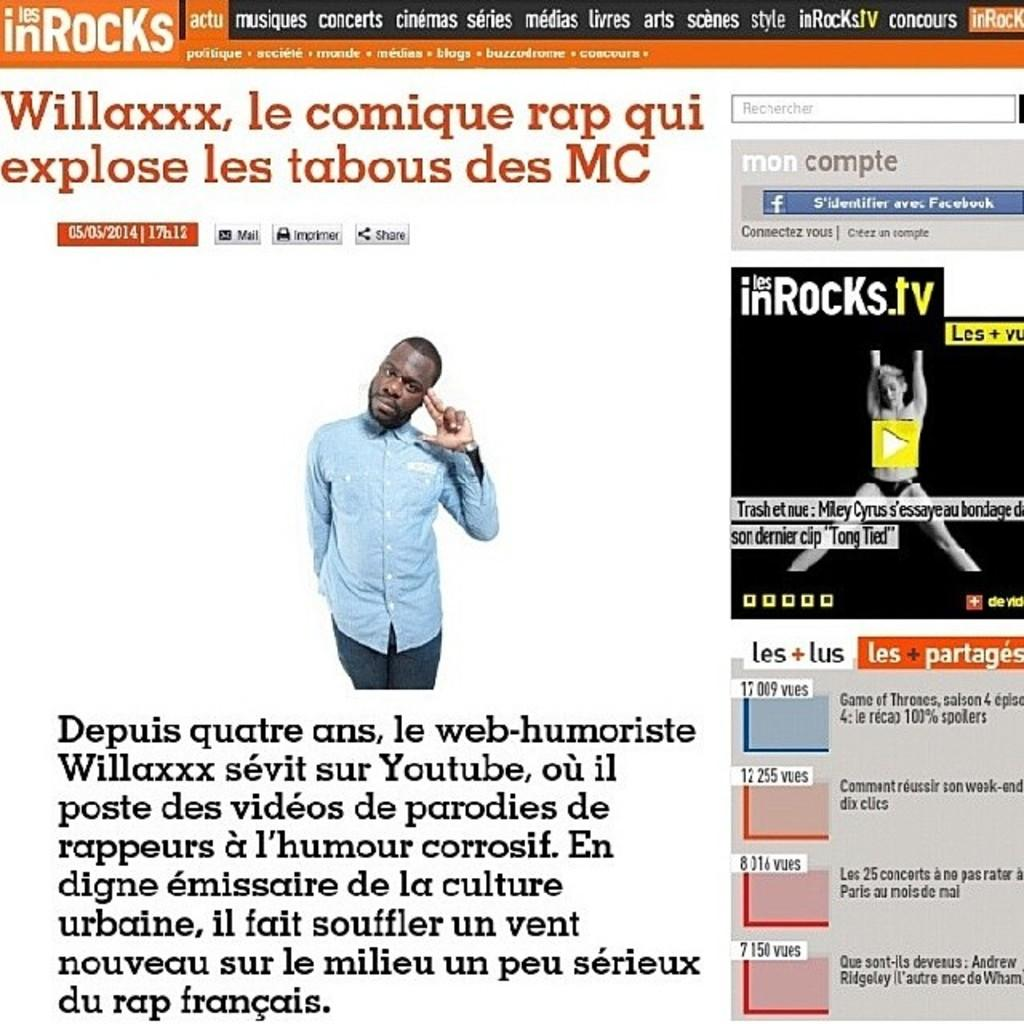Who is present on the web page? There is a man on the web page. What else can be found on the web page besides the man? There is text on the web page. What is located on the right side of the web page? There is another image on the right side of the web page. What feature does the image on the right side have? The image on the right side has a play button symbol. How many bridges are visible on the web page? There are no bridges visible on the web page. What type of support can be seen holding up the man in the image? The man is not being held up by any visible support in the image. 